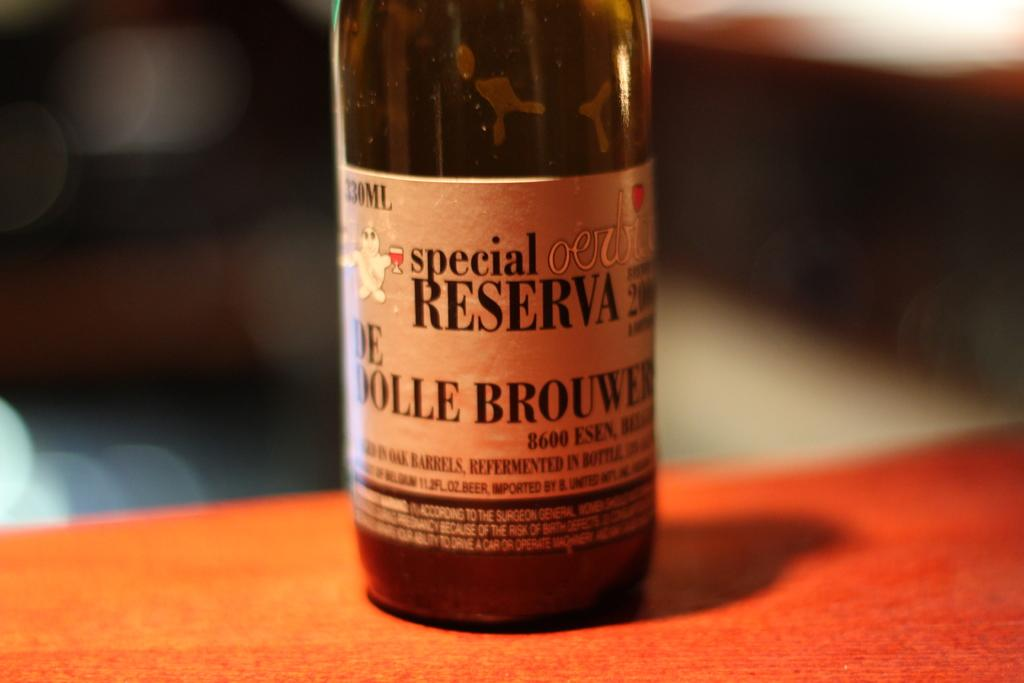Provide a one-sentence caption for the provided image. A special reserva drink on top of a counter. 